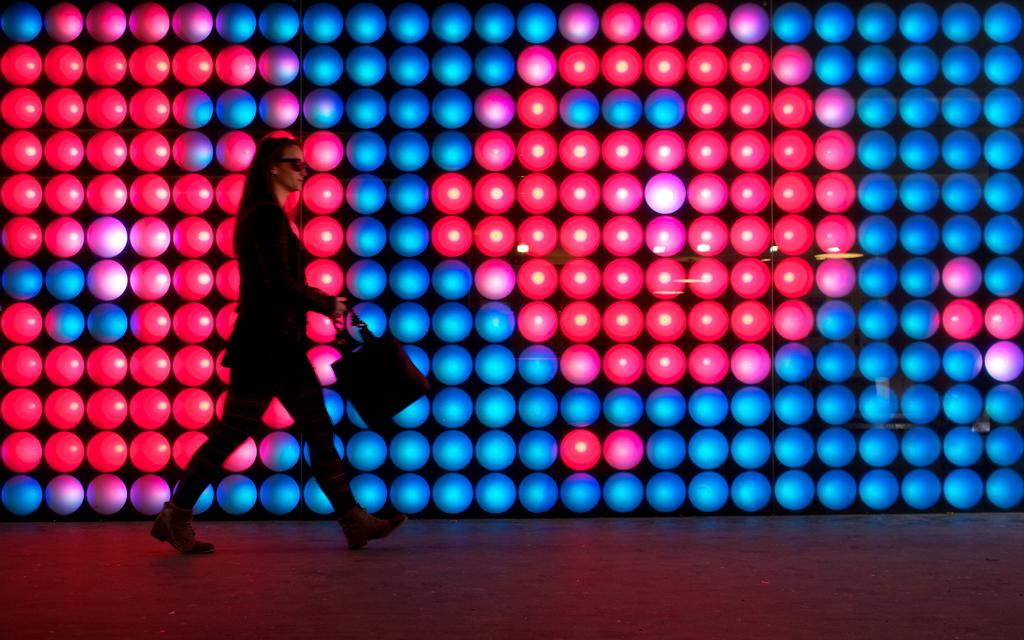Who is present in the image? There is a lady in the image. What is the lady doing in the image? The lady is walking in the image. What is the lady holding in the image? The lady is holding a handbag in the image. What can be seen in the background of the image? There are lights visible in the background of the image. What type of crown is the lady wearing in the image? There is no crown visible in the image; the lady is only holding a handbag and walking. 